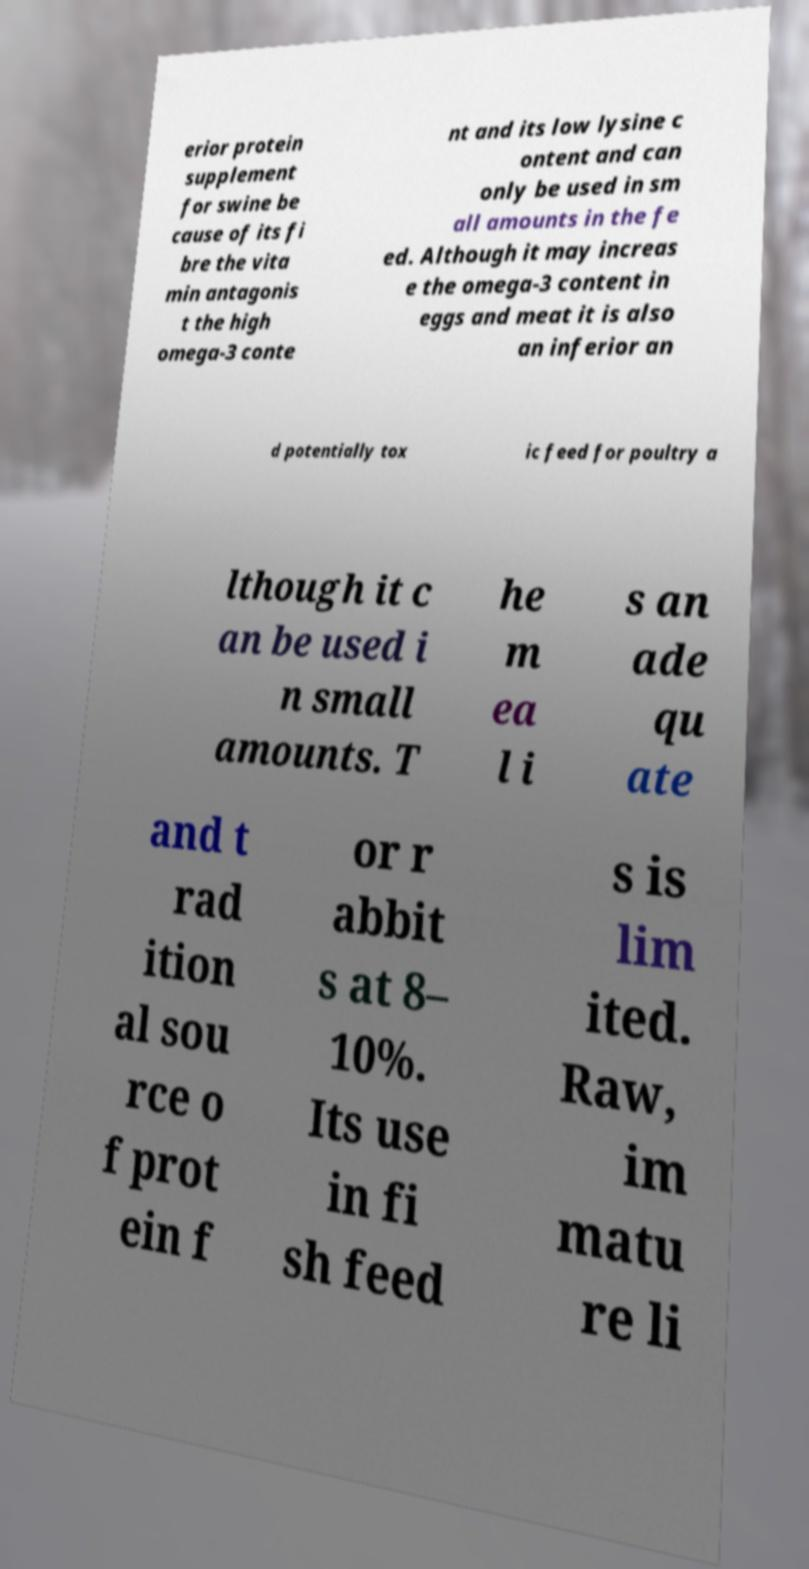Please identify and transcribe the text found in this image. erior protein supplement for swine be cause of its fi bre the vita min antagonis t the high omega-3 conte nt and its low lysine c ontent and can only be used in sm all amounts in the fe ed. Although it may increas e the omega-3 content in eggs and meat it is also an inferior an d potentially tox ic feed for poultry a lthough it c an be used i n small amounts. T he m ea l i s an ade qu ate and t rad ition al sou rce o f prot ein f or r abbit s at 8– 10%. Its use in fi sh feed s is lim ited. Raw, im matu re li 